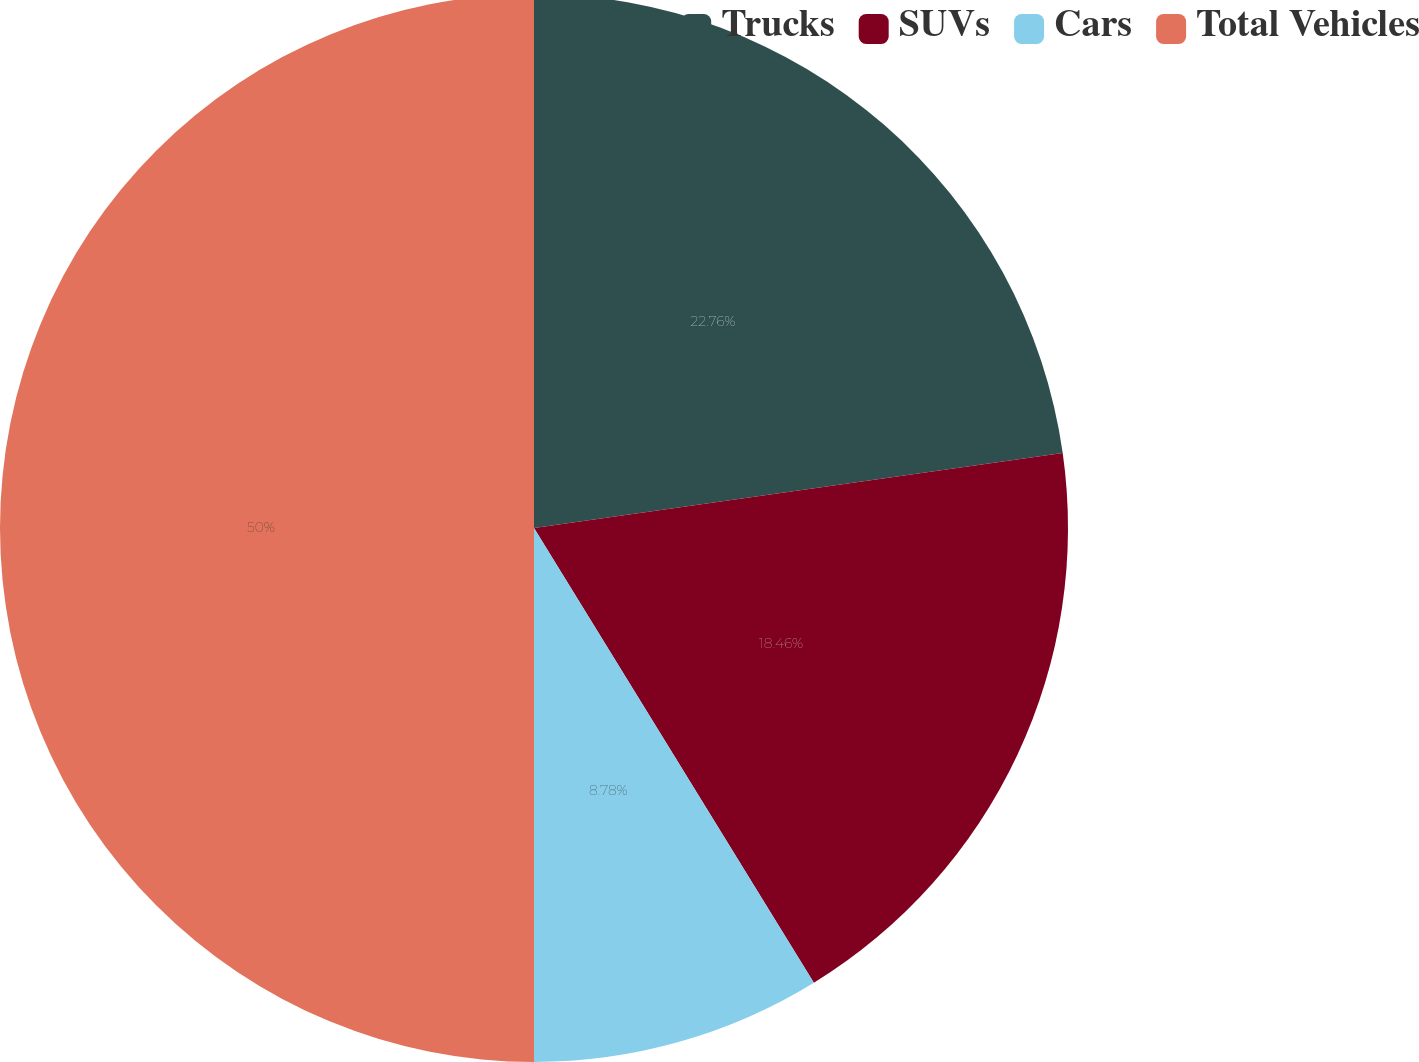Convert chart. <chart><loc_0><loc_0><loc_500><loc_500><pie_chart><fcel>Trucks<fcel>SUVs<fcel>Cars<fcel>Total Vehicles<nl><fcel>22.76%<fcel>18.46%<fcel>8.78%<fcel>50.0%<nl></chart> 